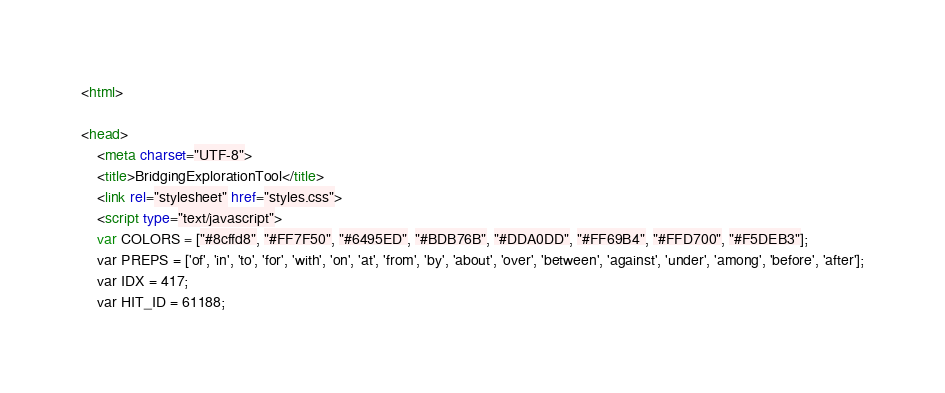<code> <loc_0><loc_0><loc_500><loc_500><_HTML_><html>

<head>
	<meta charset="UTF-8">
	<title>BridgingExplorationTool</title>
	<link rel="stylesheet" href="styles.css">
	<script type="text/javascript">
	var COLORS = ["#8cffd8", "#FF7F50", "#6495ED", "#BDB76B", "#DDA0DD", "#FF69B4", "#FFD700", "#F5DEB3"];
	var PREPS = ['of', 'in', 'to', 'for', 'with', 'on', 'at', 'from', 'by', 'about', 'over', 'between', 'against', 'under', 'among', 'before', 'after'];
	var IDX = 417;
	var HIT_ID = 61188;</code> 